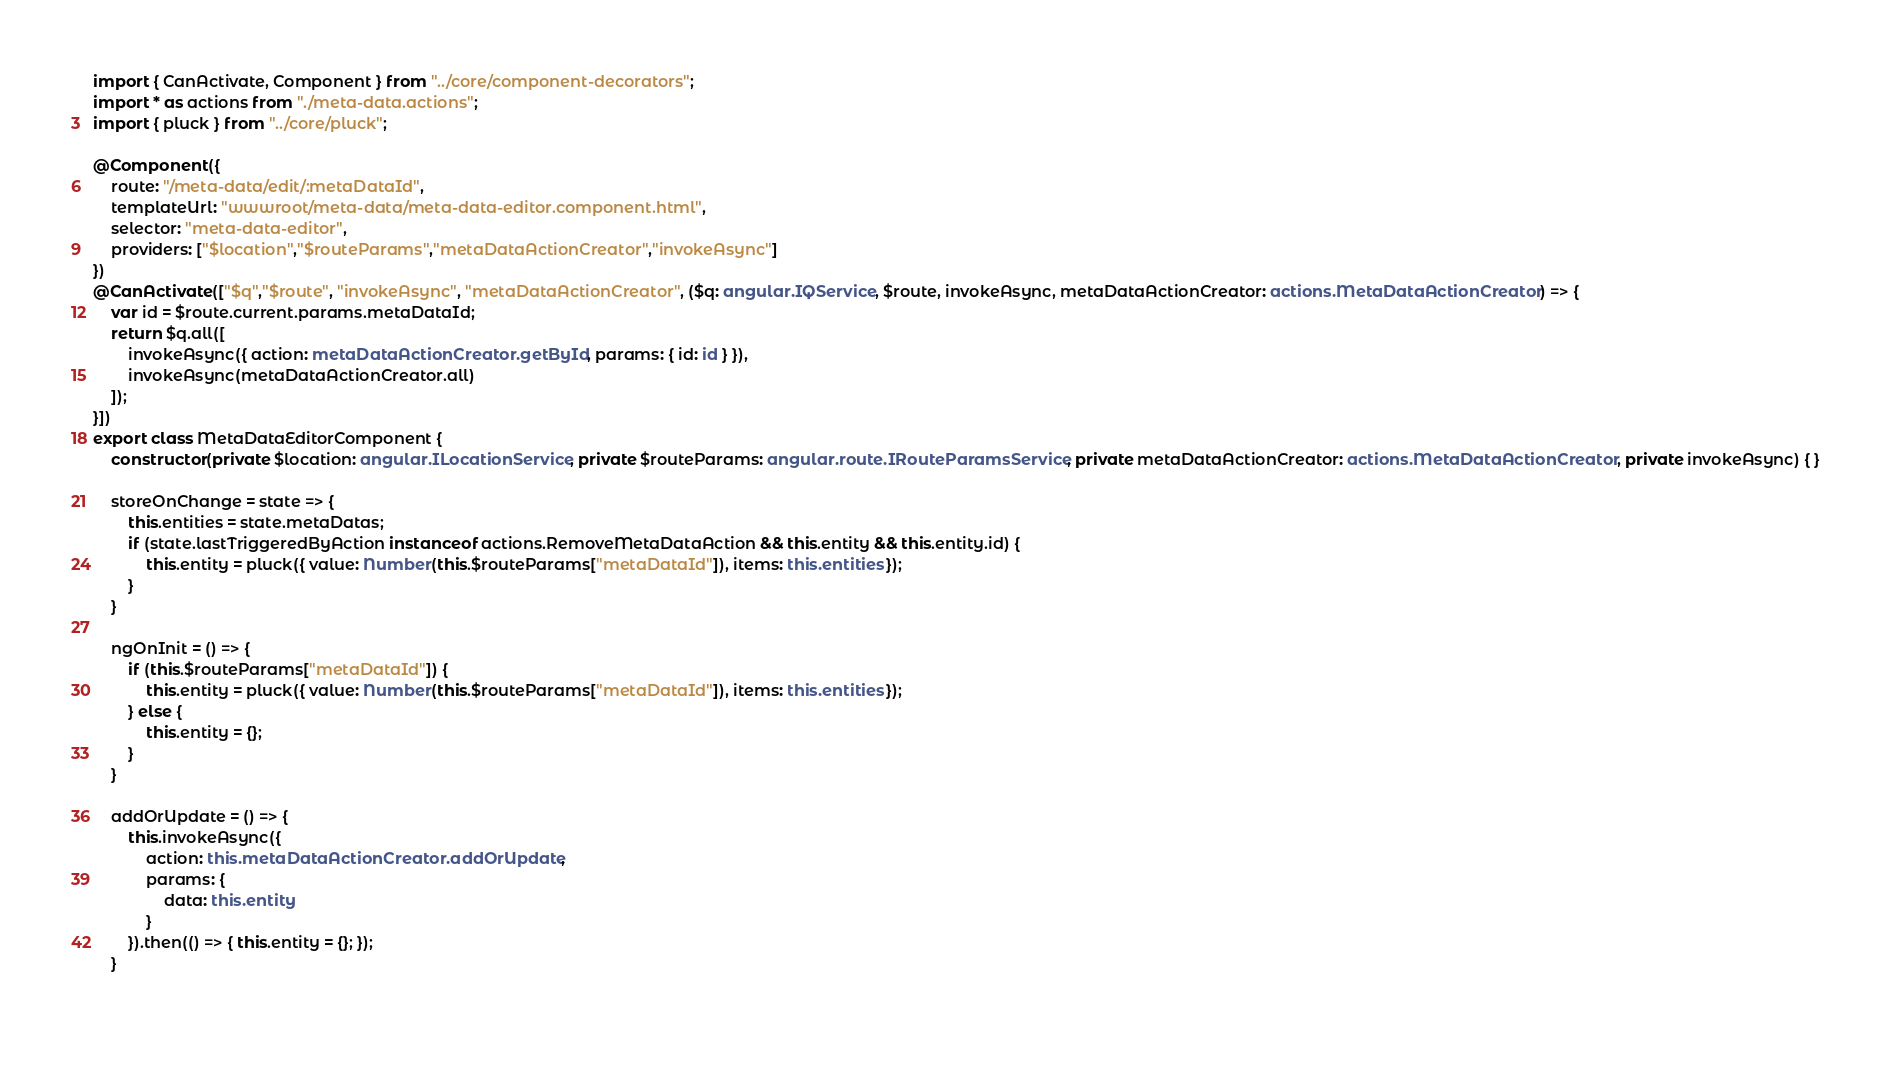<code> <loc_0><loc_0><loc_500><loc_500><_TypeScript_>import { CanActivate, Component } from "../core/component-decorators";
import * as actions from "./meta-data.actions";
import { pluck } from "../core/pluck";

@Component({
    route: "/meta-data/edit/:metaDataId",
    templateUrl: "wwwroot/meta-data/meta-data-editor.component.html",
    selector: "meta-data-editor",
    providers: ["$location","$routeParams","metaDataActionCreator","invokeAsync"]
})
@CanActivate(["$q","$route", "invokeAsync", "metaDataActionCreator", ($q: angular.IQService, $route, invokeAsync, metaDataActionCreator: actions.MetaDataActionCreator) => {
    var id = $route.current.params.metaDataId;
    return $q.all([
        invokeAsync({ action: metaDataActionCreator.getById, params: { id: id } }),
        invokeAsync(metaDataActionCreator.all)
    ]);
}])
export class MetaDataEditorComponent {
    constructor(private $location: angular.ILocationService, private $routeParams: angular.route.IRouteParamsService, private metaDataActionCreator: actions.MetaDataActionCreator, private invokeAsync) { }

	storeOnChange = state => { 
		this.entities = state.metaDatas; 
		if (state.lastTriggeredByAction instanceof actions.RemoveMetaDataAction && this.entity && this.entity.id) {
            this.entity = pluck({ value: Number(this.$routeParams["metaDataId"]), items: this.entities });
        }
	}

	ngOnInit = () => {
        if (this.$routeParams["metaDataId"]) {
            this.entity = pluck({ value: Number(this.$routeParams["metaDataId"]), items: this.entities });
        } else {
            this.entity = {};
        }
    }

    addOrUpdate = () => {
        this.invokeAsync({
            action: this.metaDataActionCreator.addOrUpdate,
            params: {
                data: this.entity
            }
        }).then(() => { this.entity = {}; });
    } 
    </code> 